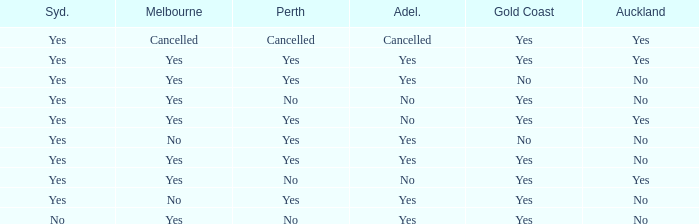Would you be able to parse every entry in this table? {'header': ['Syd.', 'Melbourne', 'Perth', 'Adel.', 'Gold Coast', 'Auckland'], 'rows': [['Yes', 'Cancelled', 'Cancelled', 'Cancelled', 'Yes', 'Yes'], ['Yes', 'Yes', 'Yes', 'Yes', 'Yes', 'Yes'], ['Yes', 'Yes', 'Yes', 'Yes', 'No', 'No'], ['Yes', 'Yes', 'No', 'No', 'Yes', 'No'], ['Yes', 'Yes', 'Yes', 'No', 'Yes', 'Yes'], ['Yes', 'No', 'Yes', 'Yes', 'No', 'No'], ['Yes', 'Yes', 'Yes', 'Yes', 'Yes', 'No'], ['Yes', 'Yes', 'No', 'No', 'Yes', 'Yes'], ['Yes', 'No', 'Yes', 'Yes', 'Yes', 'No'], ['No', 'Yes', 'No', 'Yes', 'Yes', 'No']]} What is the sydney that has adelaide, gold coast, melbourne, and auckland are all yes? Yes. 